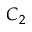<formula> <loc_0><loc_0><loc_500><loc_500>C _ { 2 }</formula> 